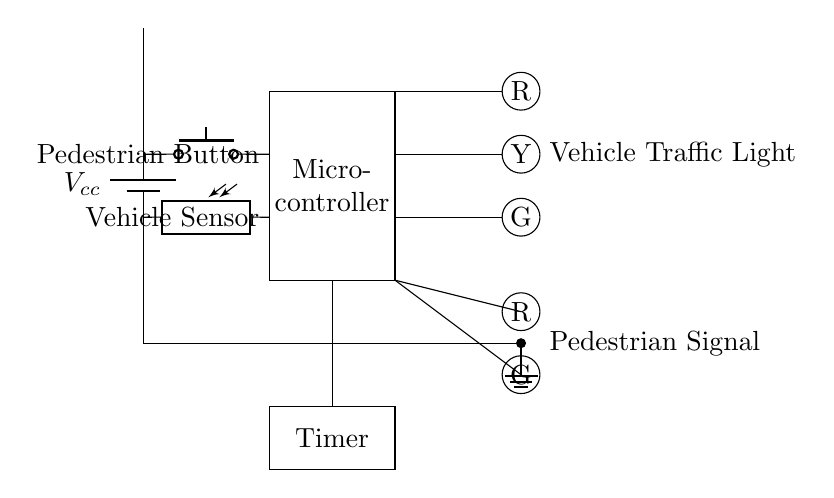What is the main controlling component in the circuit? The main controlling component is the microcontroller, which processes inputs from sensors and controls the output signals to the traffic lights.
Answer: microcontroller How many lights are there for pedestrian signaling? There are two lights designated for pedestrian signaling: a red light and a green light.
Answer: two What type of sensors are used in this circuit? The circuit uses a pedestrian button and a vehicle sensor, which detect pedestrian demand and vehicle presence, respectively.
Answer: push button and photoresistor What is the function of the timer in the circuit? The timer is responsible for controlling the duration of the light changes, ensuring that pedestrians and vehicles receive appropriate crossing times.
Answer: controls light duration What lights are present for vehicle traffic? There are three lights for vehicle traffic: a red light, a yellow light, and a green light, indicating stop, caution, and go conditions, respectively.
Answer: red, yellow, and green How does the pedestrian button affect the traffic lights? When the pedestrian button is pressed, it signals the microcontroller to prioritize pedestrian crossing, usually resulting in activating the pedestrian signal and potentially altering the vehicle light sequence.
Answer: prioritizes pedestrian crossing What type of circuit is this diagram representing? This diagram represents a control circuit specifically designed for managing traffic light operations at an intersection, especially regarding pedestrian crossings.
Answer: control circuit for traffic lights 